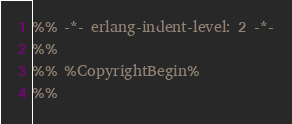Convert code to text. <code><loc_0><loc_0><loc_500><loc_500><_Erlang_>%% -*- erlang-indent-level: 2 -*-
%%
%% %CopyrightBegin%
%% </code> 